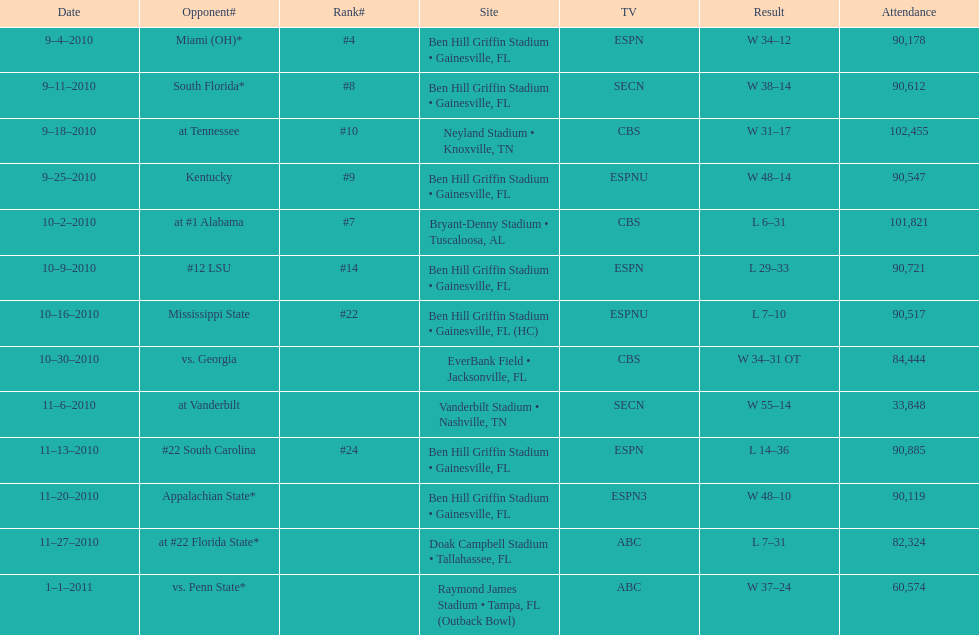How many consecutive weeks did the the gators win until the had their first lost in the 2010 season? 4. 